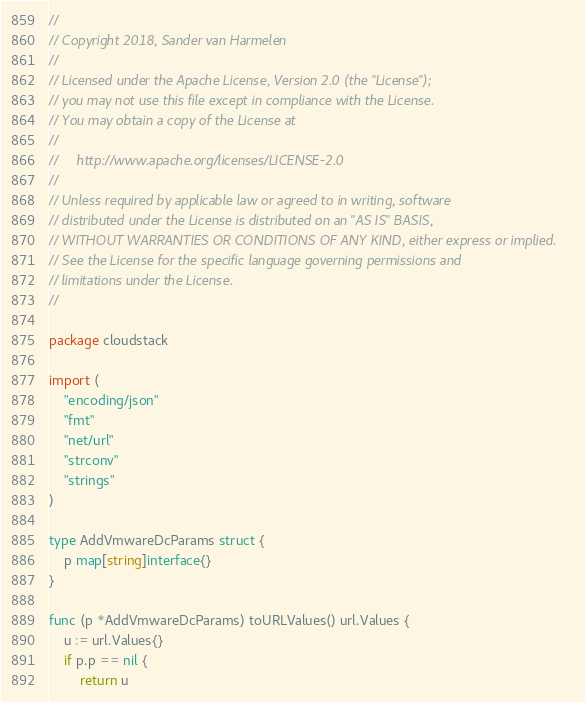<code> <loc_0><loc_0><loc_500><loc_500><_Go_>//
// Copyright 2018, Sander van Harmelen
//
// Licensed under the Apache License, Version 2.0 (the "License");
// you may not use this file except in compliance with the License.
// You may obtain a copy of the License at
//
//     http://www.apache.org/licenses/LICENSE-2.0
//
// Unless required by applicable law or agreed to in writing, software
// distributed under the License is distributed on an "AS IS" BASIS,
// WITHOUT WARRANTIES OR CONDITIONS OF ANY KIND, either express or implied.
// See the License for the specific language governing permissions and
// limitations under the License.
//

package cloudstack

import (
	"encoding/json"
	"fmt"
	"net/url"
	"strconv"
	"strings"
)

type AddVmwareDcParams struct {
	p map[string]interface{}
}

func (p *AddVmwareDcParams) toURLValues() url.Values {
	u := url.Values{}
	if p.p == nil {
		return u</code> 